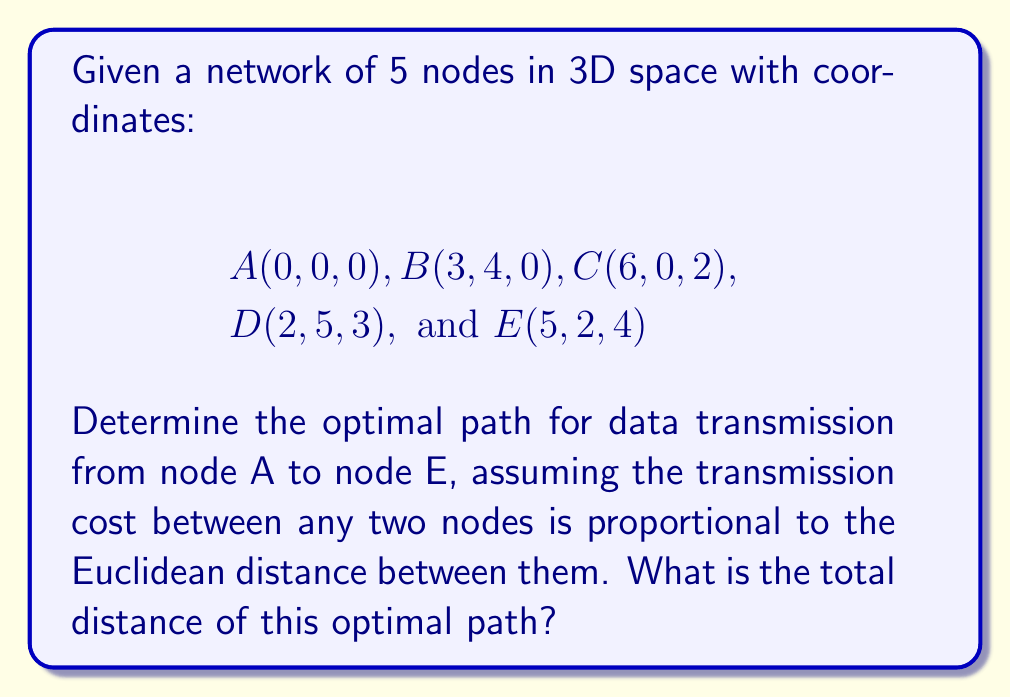Teach me how to tackle this problem. To solve this problem, we need to consider all possible paths from A to E and calculate their total distances. The optimal path will be the one with the shortest total distance.

1. Calculate distances between all pairs of nodes:
   We use the Euclidean distance formula in 3D space:
   $$d = \sqrt{(x_2-x_1)^2 + (y_2-y_1)^2 + (z_2-z_1)^2}$$

   AB = $\sqrt{3^2 + 4^2 + 0^2} = 5$
   AC = $\sqrt{6^2 + 0^2 + 2^2} = \sqrt{40} \approx 6.32$
   AD = $\sqrt{2^2 + 5^2 + 3^2} = \sqrt{38} \approx 6.16$
   AE = $\sqrt{5^2 + 2^2 + 4^2} = \sqrt{45} \approx 6.71$
   BC = $\sqrt{3^2 + (-4)^2 + 2^2} = \sqrt{29} \approx 5.39$
   BD = $\sqrt{(-1)^2 + 1^2 + 3^2} = \sqrt{11} \approx 3.32$
   BE = $\sqrt{2^2 + (-2)^2 + 4^2} = \sqrt{24} \approx 4.90$
   CD = $\sqrt{(-4)^2 + 5^2 + 1^2} = \sqrt{42} \approx 6.48$
   CE = $\sqrt{(-1)^2 + 2^2 + 2^2} = 3$
   DE = $\sqrt{3^2 + (-3)^2 + 1^2} = \sqrt{19} \approx 4.36$

2. Consider all possible paths from A to E:
   A -> E
   A -> B -> E
   A -> C -> E
   A -> D -> E
   A -> B -> C -> E
   A -> B -> D -> E
   A -> C -> D -> E
   A -> D -> C -> E

3. Calculate the total distance for each path:
   A -> E = 6.71
   A -> B -> E = 5 + 4.90 = 9.90
   A -> C -> E = 6.32 + 3 = 9.32
   A -> D -> E = 6.16 + 4.36 = 10.52
   A -> B -> C -> E = 5 + 5.39 + 3 = 13.39
   A -> B -> D -> E = 5 + 3.32 + 4.36 = 12.68
   A -> C -> D -> E = 6.32 + 6.48 + 4.36 = 17.16
   A -> D -> C -> E = 6.16 + 6.48 + 3 = 15.64

4. Identify the shortest path:
   The shortest path is A -> C -> E with a total distance of 9.32.
Answer: The optimal path for data transmission from node A to node E is A -> C -> E, with a total distance of approximately 9.32 units. 